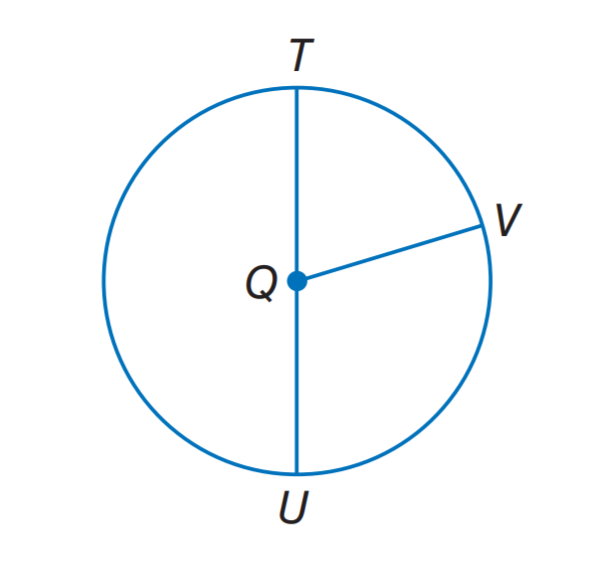Answer the mathemtical geometry problem and directly provide the correct option letter.
Question: If Q T = 11, what is Q U.
Choices: A: 7 B: 8 C: 11 D: 16 C 